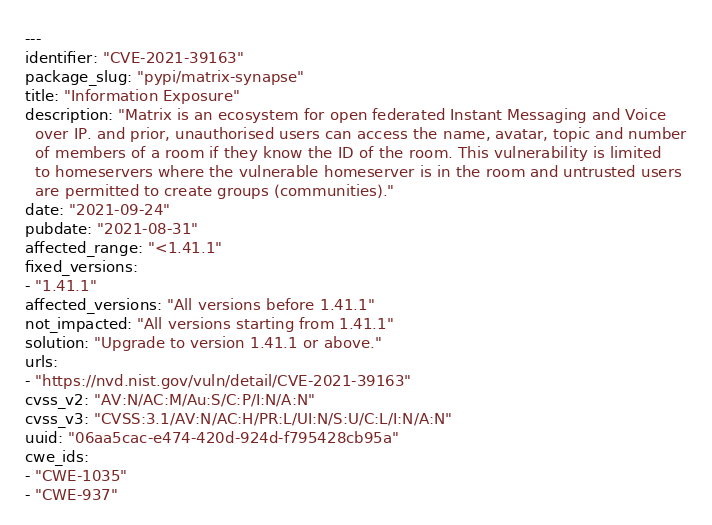Convert code to text. <code><loc_0><loc_0><loc_500><loc_500><_YAML_>---
identifier: "CVE-2021-39163"
package_slug: "pypi/matrix-synapse"
title: "Information Exposure"
description: "Matrix is an ecosystem for open federated Instant Messaging and Voice
  over IP. and prior, unauthorised users can access the name, avatar, topic and number
  of members of a room if they know the ID of the room. This vulnerability is limited
  to homeservers where the vulnerable homeserver is in the room and untrusted users
  are permitted to create groups (communities)."
date: "2021-09-24"
pubdate: "2021-08-31"
affected_range: "<1.41.1"
fixed_versions:
- "1.41.1"
affected_versions: "All versions before 1.41.1"
not_impacted: "All versions starting from 1.41.1"
solution: "Upgrade to version 1.41.1 or above."
urls:
- "https://nvd.nist.gov/vuln/detail/CVE-2021-39163"
cvss_v2: "AV:N/AC:M/Au:S/C:P/I:N/A:N"
cvss_v3: "CVSS:3.1/AV:N/AC:H/PR:L/UI:N/S:U/C:L/I:N/A:N"
uuid: "06aa5cac-e474-420d-924d-f795428cb95a"
cwe_ids:
- "CWE-1035"
- "CWE-937"
</code> 